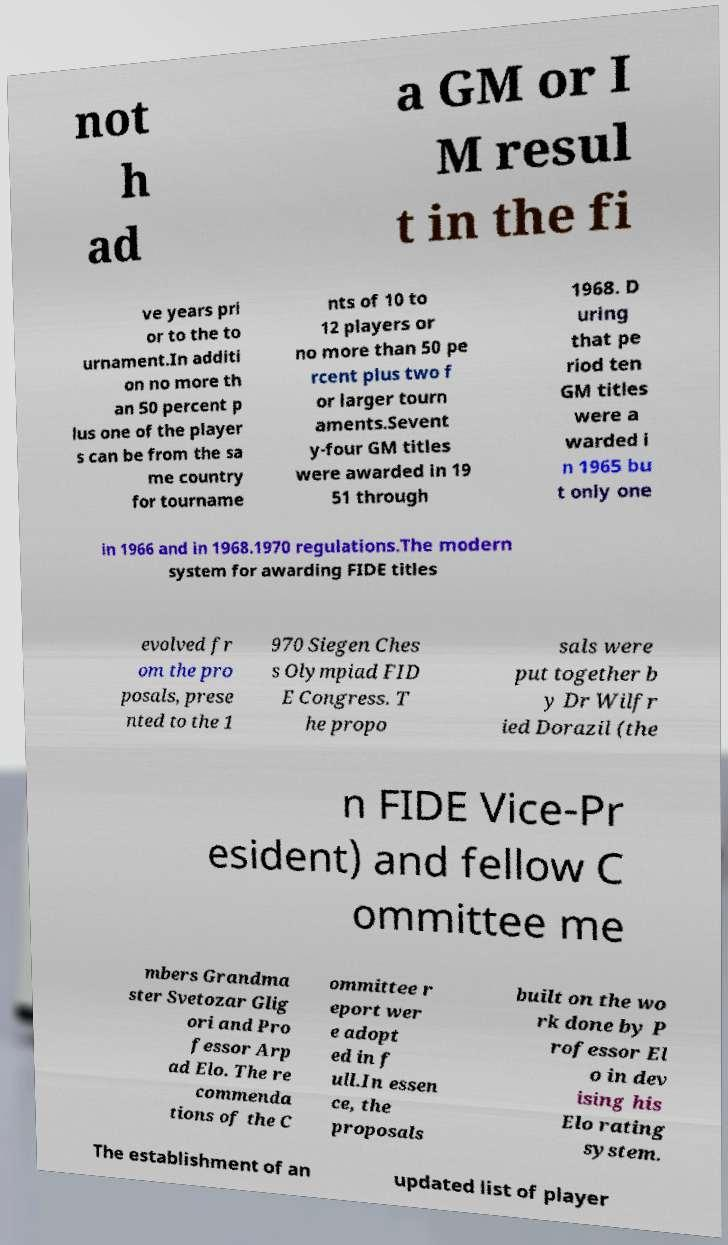For documentation purposes, I need the text within this image transcribed. Could you provide that? not h ad a GM or I M resul t in the fi ve years pri or to the to urnament.In additi on no more th an 50 percent p lus one of the player s can be from the sa me country for tourname nts of 10 to 12 players or no more than 50 pe rcent plus two f or larger tourn aments.Sevent y-four GM titles were awarded in 19 51 through 1968. D uring that pe riod ten GM titles were a warded i n 1965 bu t only one in 1966 and in 1968.1970 regulations.The modern system for awarding FIDE titles evolved fr om the pro posals, prese nted to the 1 970 Siegen Ches s Olympiad FID E Congress. T he propo sals were put together b y Dr Wilfr ied Dorazil (the n FIDE Vice-Pr esident) and fellow C ommittee me mbers Grandma ster Svetozar Glig ori and Pro fessor Arp ad Elo. The re commenda tions of the C ommittee r eport wer e adopt ed in f ull.In essen ce, the proposals built on the wo rk done by P rofessor El o in dev ising his Elo rating system. The establishment of an updated list of player 